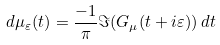<formula> <loc_0><loc_0><loc_500><loc_500>d \mu _ { \varepsilon } ( t ) = \frac { - 1 } { \pi } \Im ( G _ { \mu } ( t + i \varepsilon ) ) \, d t</formula> 